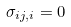<formula> <loc_0><loc_0><loc_500><loc_500>\sigma _ { i j , i } = 0</formula> 